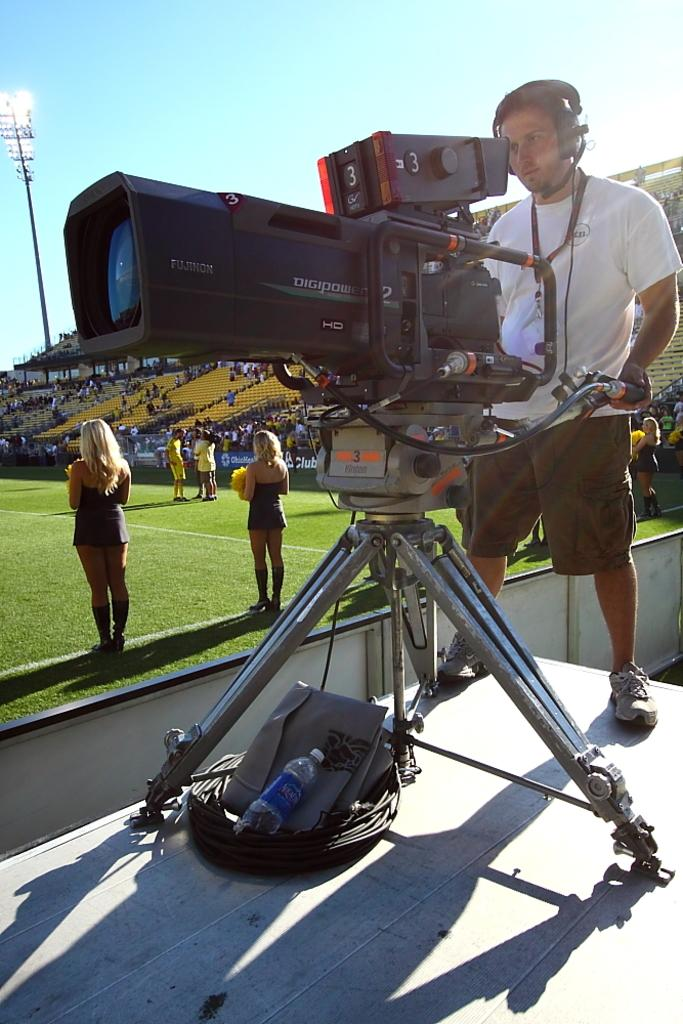<image>
Render a clear and concise summary of the photo. A man operates a large Digipower camera on the field of a sports game. 